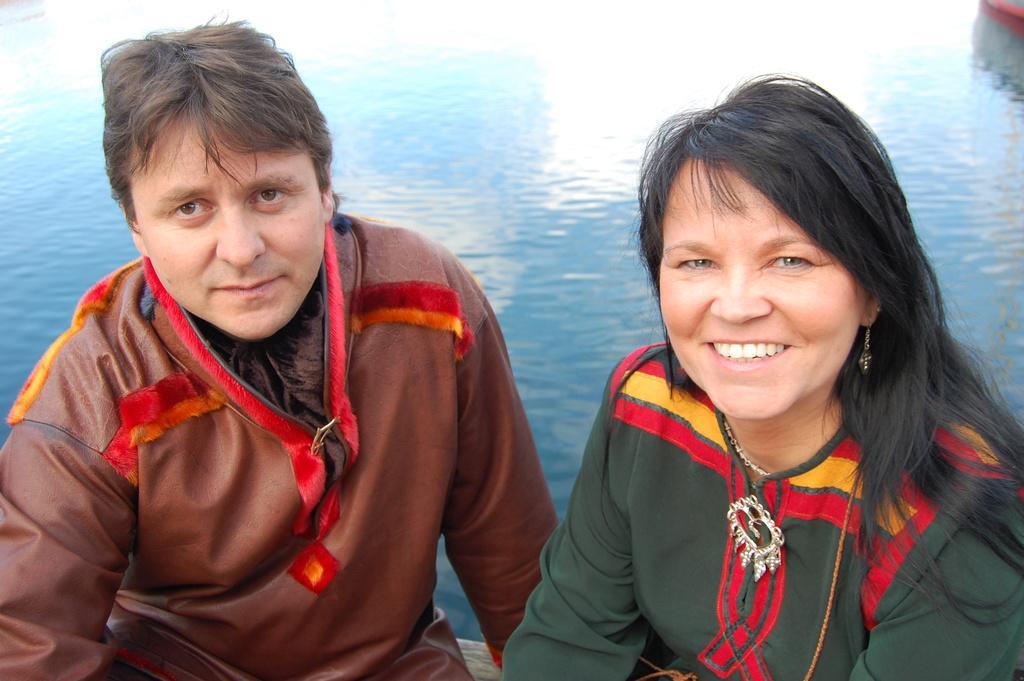In one or two sentences, can you explain what this image depicts? In this picture we can see a man and a woman are sitting and smiling in the front, there is water in the background. 